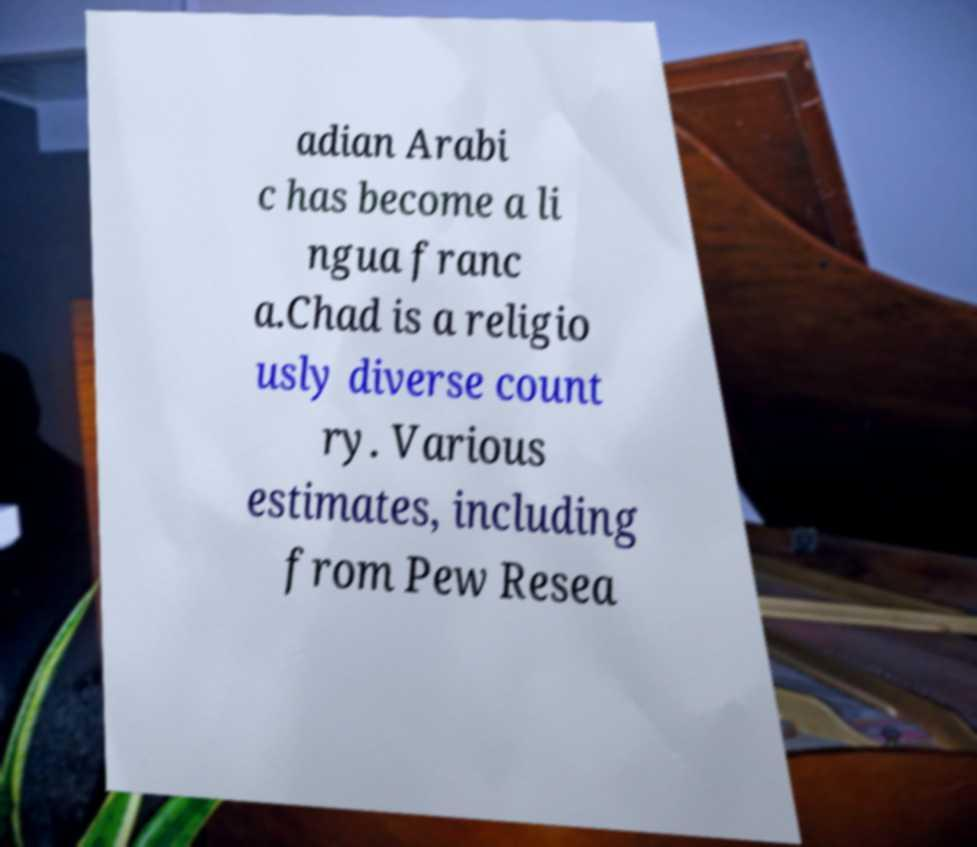For documentation purposes, I need the text within this image transcribed. Could you provide that? adian Arabi c has become a li ngua franc a.Chad is a religio usly diverse count ry. Various estimates, including from Pew Resea 